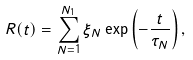<formula> <loc_0><loc_0><loc_500><loc_500>R ( t ) = \sum _ { N = 1 } ^ { N _ { 1 } } \xi _ { N } \exp \left ( - \frac { t } { \tau _ { N } } \right ) ,</formula> 